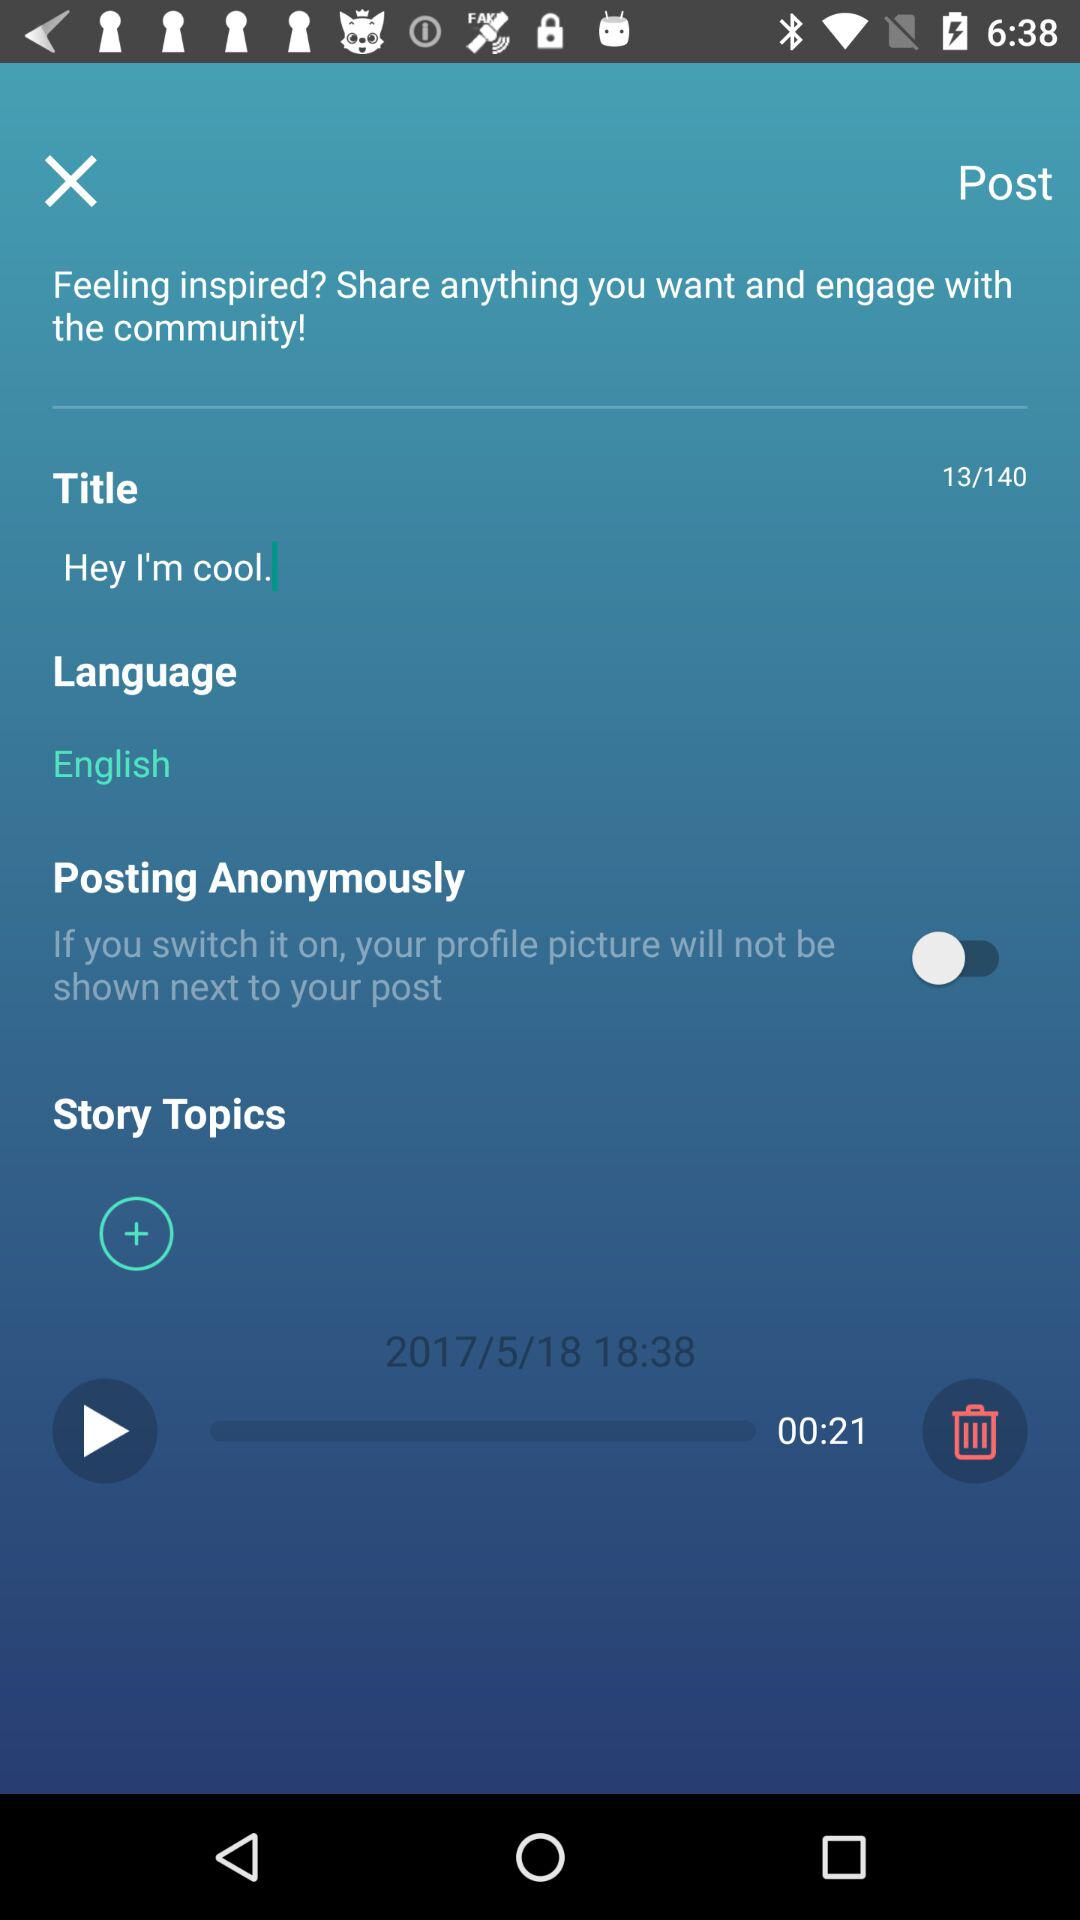What is the date? The date is May 18, 2017. 